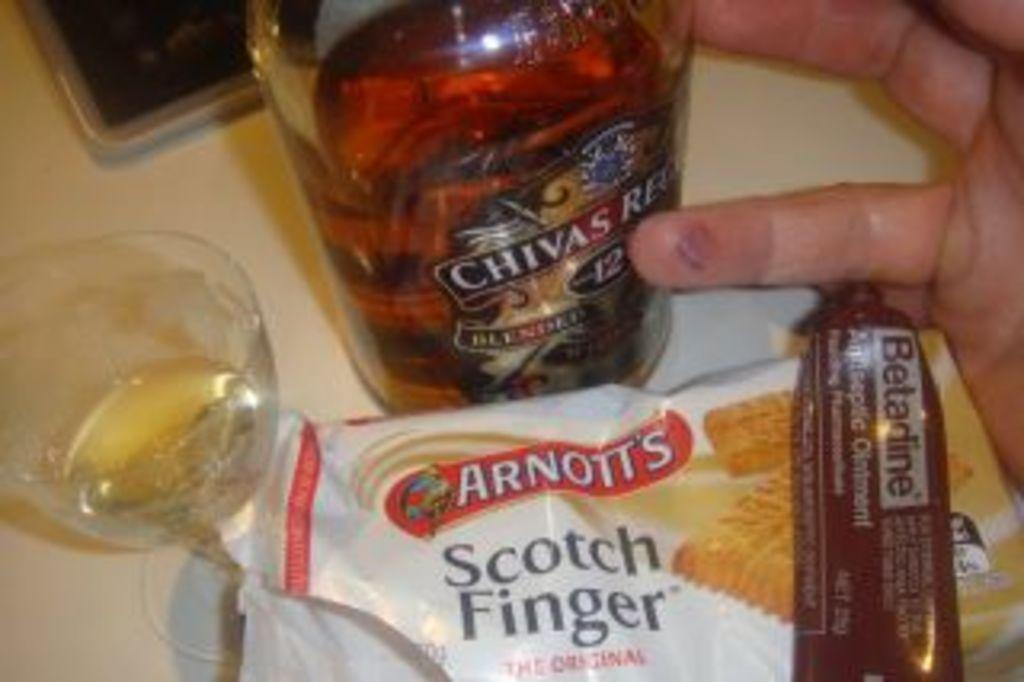What brand of alcohol?
Provide a succinct answer. Chivas. 